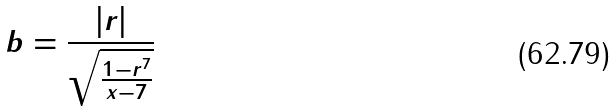Convert formula to latex. <formula><loc_0><loc_0><loc_500><loc_500>b = \frac { | r | } { \sqrt { \frac { 1 - r ^ { 7 } } { x - 7 } } }</formula> 